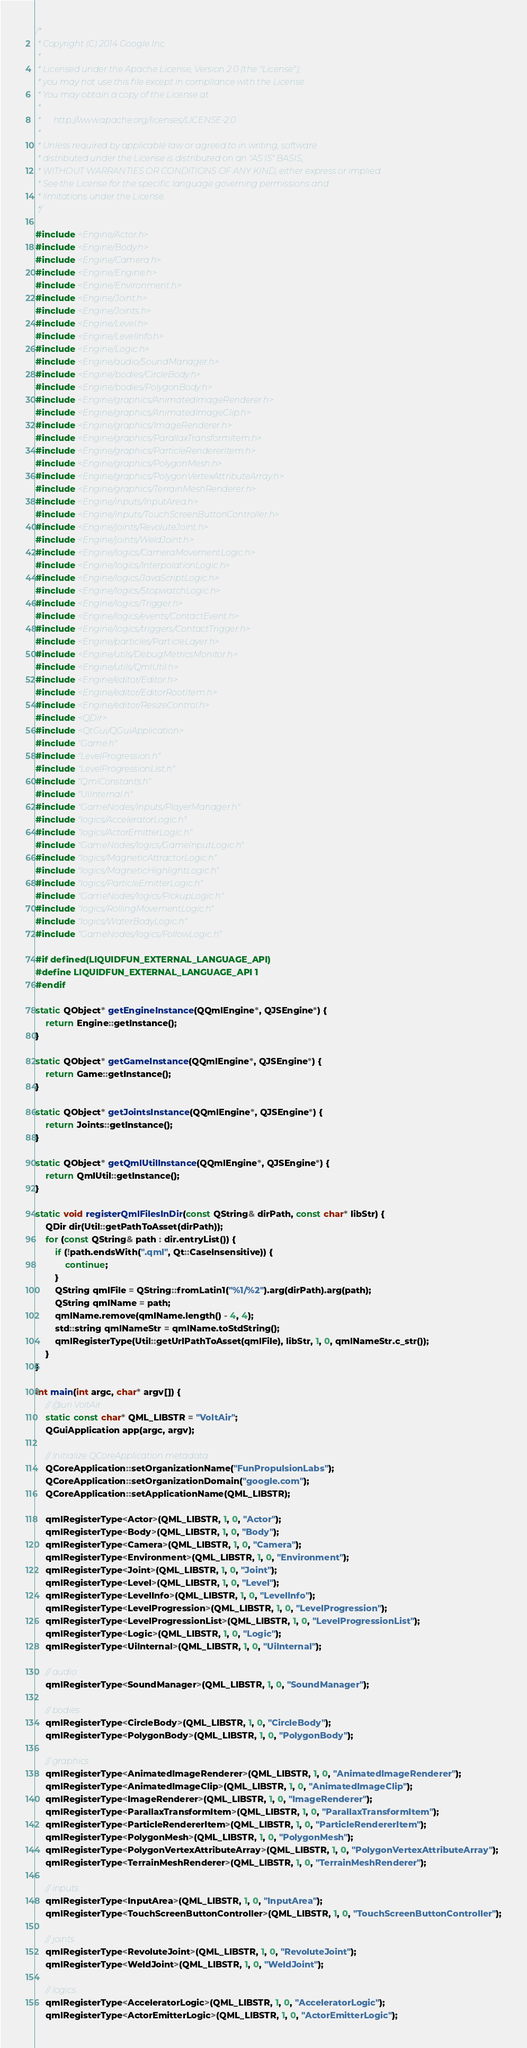Convert code to text. <code><loc_0><loc_0><loc_500><loc_500><_C++_>/*
 * Copyright (C) 2014 Google Inc.
 *
 * Licensed under the Apache License, Version 2.0 (the "License");
 * you may not use this file except in compliance with the License.
 * You may obtain a copy of the License at
 *
 *      http://www.apache.org/licenses/LICENSE-2.0
 *
 * Unless required by applicable law or agreed to in writing, software
 * distributed under the License is distributed on an "AS IS" BASIS,
 * WITHOUT WARRANTIES OR CONDITIONS OF ANY KIND, either express or implied.
 * See the License for the specific language governing permissions and
 * limitations under the License.
 */

#include <Engine/Actor.h>
#include <Engine/Body.h>
#include <Engine/Camera.h>
#include <Engine/Engine.h>
#include <Engine/Environment.h>
#include <Engine/Joint.h>
#include <Engine/Joints.h>
#include <Engine/Level.h>
#include <Engine/LevelInfo.h>
#include <Engine/Logic.h>
#include <Engine/audio/SoundManager.h>
#include <Engine/bodies/CircleBody.h>
#include <Engine/bodies/PolygonBody.h>
#include <Engine/graphics/AnimatedImageRenderer.h>
#include <Engine/graphics/AnimatedImageClip.h>
#include <Engine/graphics/ImageRenderer.h>
#include <Engine/graphics/ParallaxTransformItem.h>
#include <Engine/graphics/ParticleRendererItem.h>
#include <Engine/graphics/PolygonMesh.h>
#include <Engine/graphics/PolygonVertexAttributeArray.h>
#include <Engine/graphics/TerrainMeshRenderer.h>
#include <Engine/inputs/InputArea.h>
#include <Engine/inputs/TouchScreenButtonController.h>
#include <Engine/joints/RevoluteJoint.h>
#include <Engine/joints/WeldJoint.h>
#include <Engine/logics/CameraMovementLogic.h>
#include <Engine/logics/InterpolationLogic.h>
#include <Engine/logics/JavaScriptLogic.h>
#include <Engine/logics/StopwatchLogic.h>
#include <Engine/logics/Trigger.h>
#include <Engine/logics/events/ContactEvent.h>
#include <Engine/logics/triggers/ContactTrigger.h>
#include <Engine/particles/ParticleLayer.h>
#include <Engine/utils/DebugMetricsMonitor.h>
#include <Engine/utils/QmlUtil.h>
#include <Engine/editor/Editor.h>
#include <Engine/editor/EditorRootItem.h>
#include <Engine/editor/ResizeControl.h>
#include <QDir>
#include <QtGui/QGuiApplication>
#include "Game.h"
#include "LevelProgression.h"
#include "LevelProgressionList.h"
#include "QmlConstants.h"
#include "UiInternal.h"
#include "GameNodes/inputs/PlayerManager.h"
#include "logics/AcceleratorLogic.h"
#include "logics/ActorEmitterLogic.h"
#include "GameNodes/logics/GameInputLogic.h"
#include "logics/MagneticAttractorLogic.h"
#include "logics/MagneticHighlightLogic.h"
#include "logics/ParticleEmitterLogic.h"
#include "GameNodes/logics/PickupLogic.h"
#include "logics/RollingMovementLogic.h"
#include "logics/WaterBodyLogic.h"
#include "GameNodes/logics/FollowLogic.h"

#if defined(LIQUIDFUN_EXTERNAL_LANGUAGE_API)
#define LIQUIDFUN_EXTERNAL_LANGUAGE_API 1
#endif

static QObject* getEngineInstance(QQmlEngine*, QJSEngine*) {
    return Engine::getInstance();
}

static QObject* getGameInstance(QQmlEngine*, QJSEngine*) {
    return Game::getInstance();
}

static QObject* getJointsInstance(QQmlEngine*, QJSEngine*) {
    return Joints::getInstance();
}

static QObject* getQmlUtilInstance(QQmlEngine*, QJSEngine*) {
    return QmlUtil::getInstance();
}

static void registerQmlFilesInDir(const QString& dirPath, const char* libStr) {
    QDir dir(Util::getPathToAsset(dirPath));
    for (const QString& path : dir.entryList()) {
        if (!path.endsWith(".qml", Qt::CaseInsensitive)) {
            continue;
        }
        QString qmlFile = QString::fromLatin1("%1/%2").arg(dirPath).arg(path);
        QString qmlName = path;
        qmlName.remove(qmlName.length() - 4, 4);
        std::string qmlNameStr = qmlName.toStdString();
        qmlRegisterType(Util::getUrlPathToAsset(qmlFile), libStr, 1, 0, qmlNameStr.c_str());
    }
}

int main(int argc, char* argv[]) {
    // @uri VoltAir
    static const char* QML_LIBSTR = "VoltAir";
    QGuiApplication app(argc, argv);

    // Initialize QCoreApplication metadata
    QCoreApplication::setOrganizationName("FunPropulsionLabs");
    QCoreApplication::setOrganizationDomain("google.com");
    QCoreApplication::setApplicationName(QML_LIBSTR);

    qmlRegisterType<Actor>(QML_LIBSTR, 1, 0, "Actor");
    qmlRegisterType<Body>(QML_LIBSTR, 1, 0, "Body");
    qmlRegisterType<Camera>(QML_LIBSTR, 1, 0, "Camera");
    qmlRegisterType<Environment>(QML_LIBSTR, 1, 0, "Environment");
    qmlRegisterType<Joint>(QML_LIBSTR, 1, 0, "Joint");
    qmlRegisterType<Level>(QML_LIBSTR, 1, 0, "Level");
    qmlRegisterType<LevelInfo>(QML_LIBSTR, 1, 0, "LevelInfo");
    qmlRegisterType<LevelProgression>(QML_LIBSTR, 1, 0, "LevelProgression");
    qmlRegisterType<LevelProgressionList>(QML_LIBSTR, 1, 0, "LevelProgressionList");
    qmlRegisterType<Logic>(QML_LIBSTR, 1, 0, "Logic");
    qmlRegisterType<UiInternal>(QML_LIBSTR, 1, 0, "UiInternal");

    // audio
    qmlRegisterType<SoundManager>(QML_LIBSTR, 1, 0, "SoundManager");

    // bodies
    qmlRegisterType<CircleBody>(QML_LIBSTR, 1, 0, "CircleBody");
    qmlRegisterType<PolygonBody>(QML_LIBSTR, 1, 0, "PolygonBody");

    // graphics
    qmlRegisterType<AnimatedImageRenderer>(QML_LIBSTR, 1, 0, "AnimatedImageRenderer");
    qmlRegisterType<AnimatedImageClip>(QML_LIBSTR, 1, 0, "AnimatedImageClip");
    qmlRegisterType<ImageRenderer>(QML_LIBSTR, 1, 0, "ImageRenderer");
    qmlRegisterType<ParallaxTransformItem>(QML_LIBSTR, 1, 0, "ParallaxTransformItem");
    qmlRegisterType<ParticleRendererItem>(QML_LIBSTR, 1, 0, "ParticleRendererItem");
    qmlRegisterType<PolygonMesh>(QML_LIBSTR, 1, 0, "PolygonMesh");
    qmlRegisterType<PolygonVertexAttributeArray>(QML_LIBSTR, 1, 0, "PolygonVertexAttributeArray");
    qmlRegisterType<TerrainMeshRenderer>(QML_LIBSTR, 1, 0, "TerrainMeshRenderer");

    // inputs
    qmlRegisterType<InputArea>(QML_LIBSTR, 1, 0, "InputArea");
    qmlRegisterType<TouchScreenButtonController>(QML_LIBSTR, 1, 0, "TouchScreenButtonController");

    // joints
    qmlRegisterType<RevoluteJoint>(QML_LIBSTR, 1, 0, "RevoluteJoint");
    qmlRegisterType<WeldJoint>(QML_LIBSTR, 1, 0, "WeldJoint");

    // logics
    qmlRegisterType<AcceleratorLogic>(QML_LIBSTR, 1, 0, "AcceleratorLogic");
    qmlRegisterType<ActorEmitterLogic>(QML_LIBSTR, 1, 0, "ActorEmitterLogic");</code> 